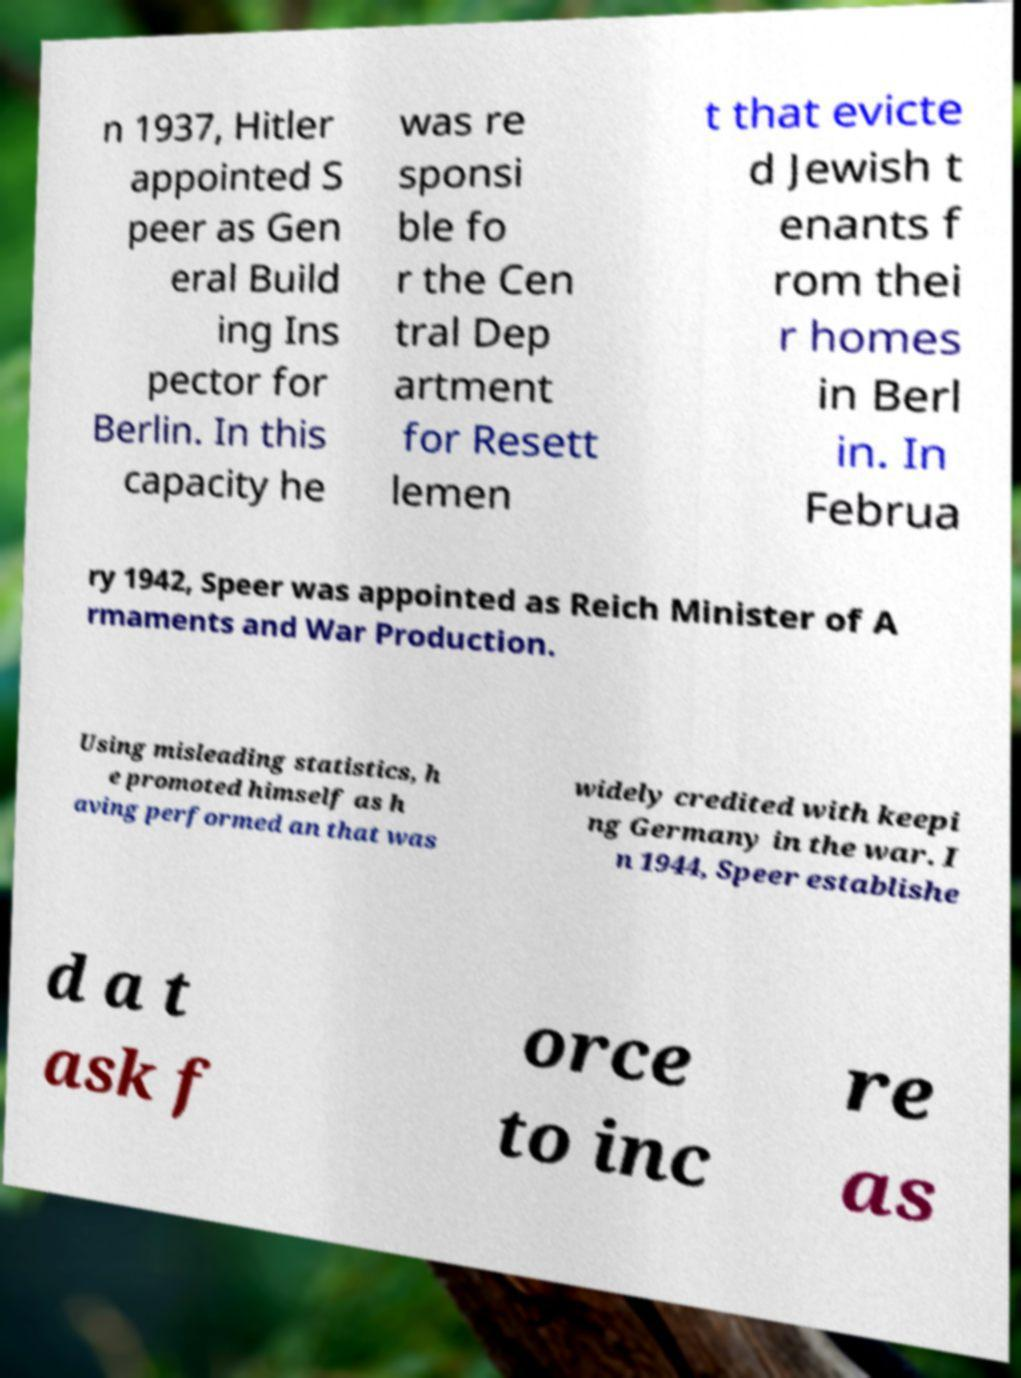Could you extract and type out the text from this image? n 1937, Hitler appointed S peer as Gen eral Build ing Ins pector for Berlin. In this capacity he was re sponsi ble fo r the Cen tral Dep artment for Resett lemen t that evicte d Jewish t enants f rom thei r homes in Berl in. In Februa ry 1942, Speer was appointed as Reich Minister of A rmaments and War Production. Using misleading statistics, h e promoted himself as h aving performed an that was widely credited with keepi ng Germany in the war. I n 1944, Speer establishe d a t ask f orce to inc re as 